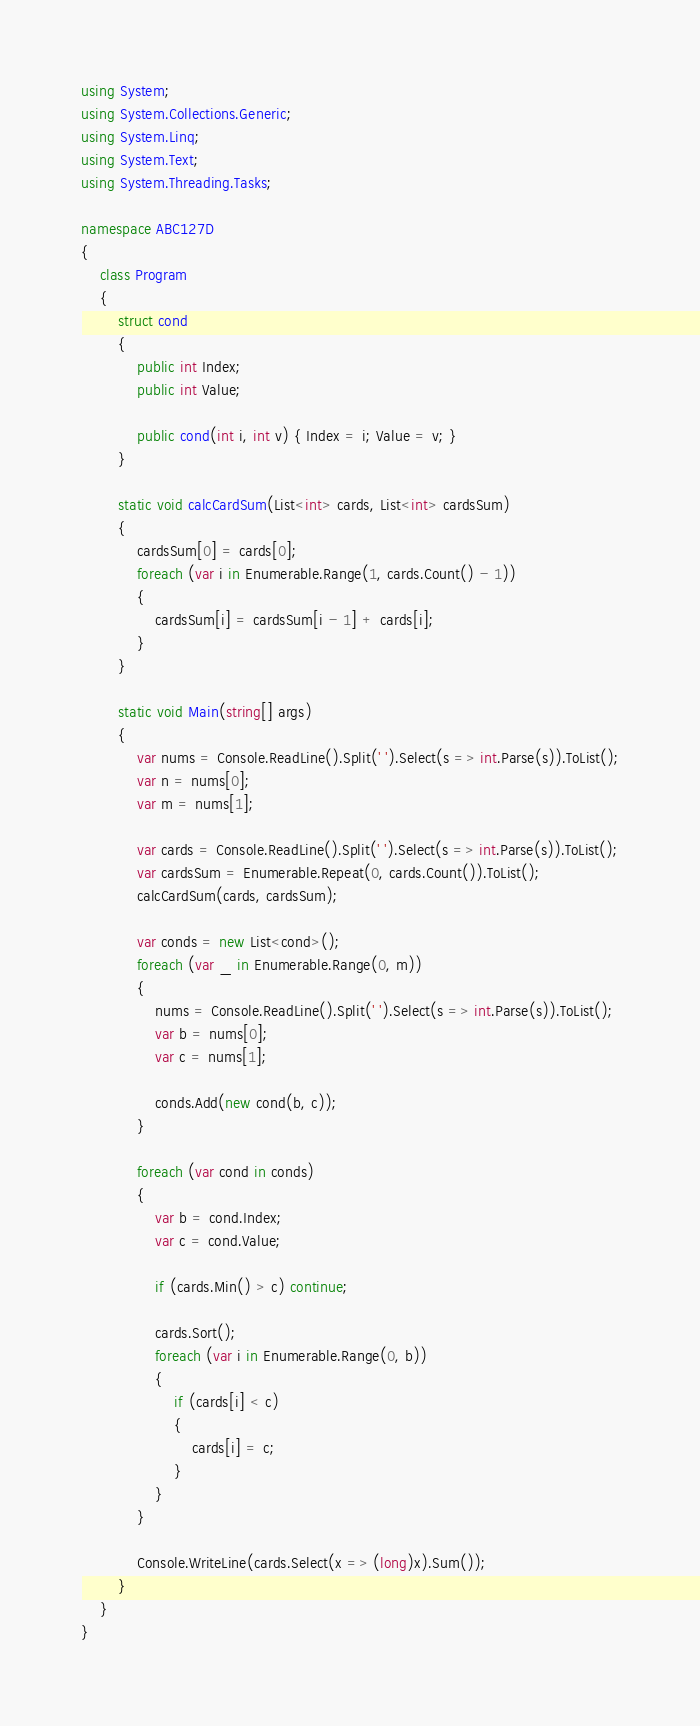Convert code to text. <code><loc_0><loc_0><loc_500><loc_500><_C#_>using System;
using System.Collections.Generic;
using System.Linq;
using System.Text;
using System.Threading.Tasks;

namespace ABC127D
{
    class Program
    {
        struct cond
        {
            public int Index;
            public int Value;

            public cond(int i, int v) { Index = i; Value = v; }
        }

        static void calcCardSum(List<int> cards, List<int> cardsSum)
        {
            cardsSum[0] = cards[0];
            foreach (var i in Enumerable.Range(1, cards.Count() - 1))
            {
                cardsSum[i] = cardsSum[i - 1] + cards[i];
            }
        }

        static void Main(string[] args)
        {
            var nums = Console.ReadLine().Split(' ').Select(s => int.Parse(s)).ToList();
            var n = nums[0];
            var m = nums[1];

            var cards = Console.ReadLine().Split(' ').Select(s => int.Parse(s)).ToList();
            var cardsSum = Enumerable.Repeat(0, cards.Count()).ToList();
            calcCardSum(cards, cardsSum);

            var conds = new List<cond>();
            foreach (var _ in Enumerable.Range(0, m))
            {
                nums = Console.ReadLine().Split(' ').Select(s => int.Parse(s)).ToList();
                var b = nums[0];
                var c = nums[1];

                conds.Add(new cond(b, c));
            }

            foreach (var cond in conds)
            {
                var b = cond.Index;
                var c = cond.Value;

                if (cards.Min() > c) continue;

                cards.Sort();
                foreach (var i in Enumerable.Range(0, b))
                {
                    if (cards[i] < c)
                    {
                        cards[i] = c;
                    }
                }
            }

            Console.WriteLine(cards.Select(x => (long)x).Sum());
        }
    }
}
</code> 